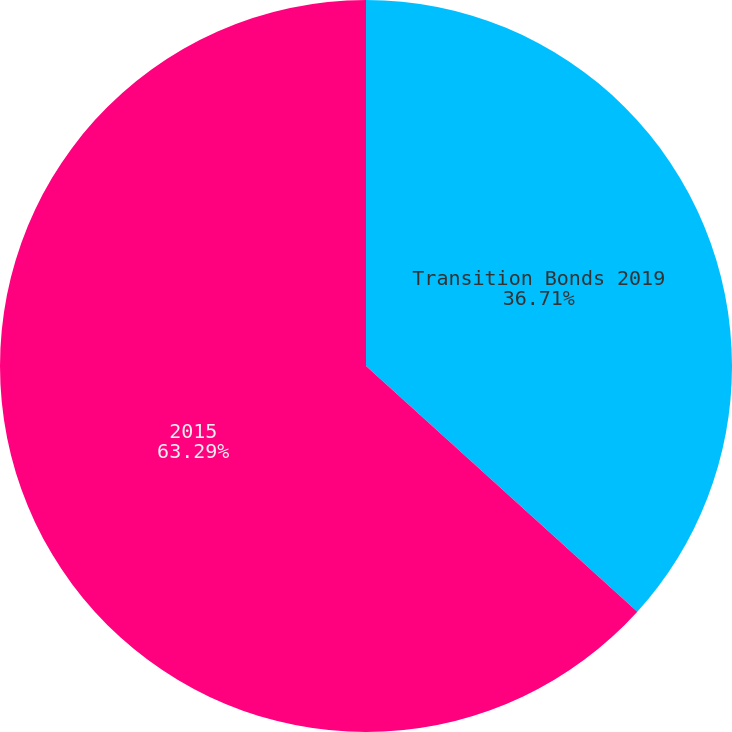Convert chart. <chart><loc_0><loc_0><loc_500><loc_500><pie_chart><fcel>Transition Bonds 2019<fcel>2015<nl><fcel>36.71%<fcel>63.29%<nl></chart> 